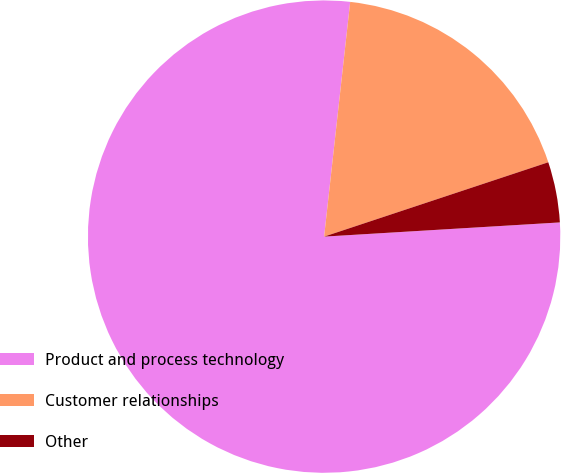<chart> <loc_0><loc_0><loc_500><loc_500><pie_chart><fcel>Product and process technology<fcel>Customer relationships<fcel>Other<nl><fcel>77.71%<fcel>18.14%<fcel>4.14%<nl></chart> 